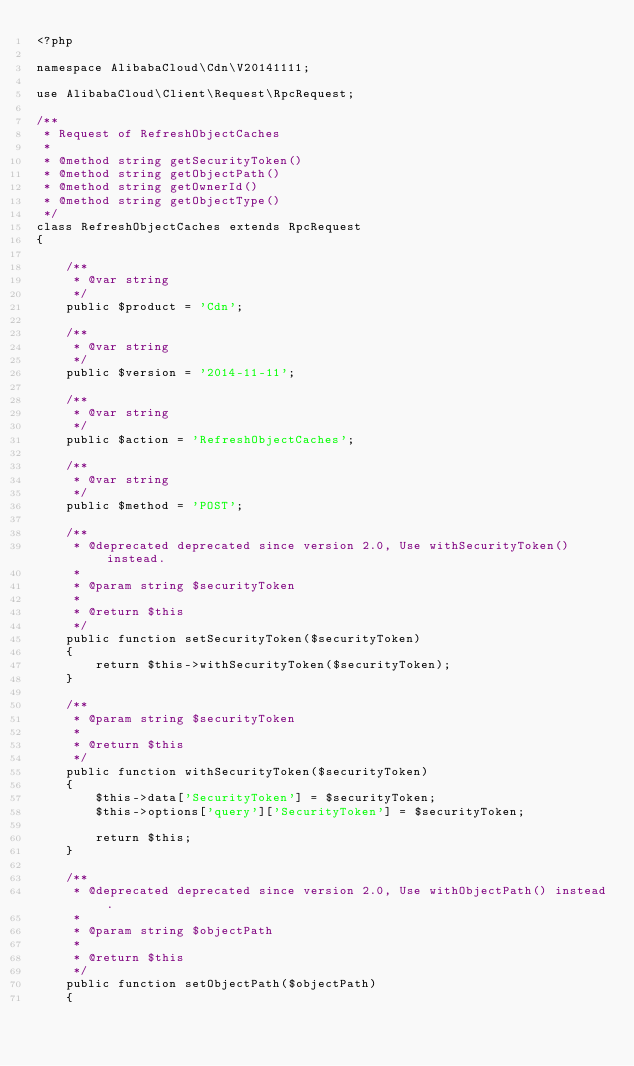Convert code to text. <code><loc_0><loc_0><loc_500><loc_500><_PHP_><?php

namespace AlibabaCloud\Cdn\V20141111;

use AlibabaCloud\Client\Request\RpcRequest;

/**
 * Request of RefreshObjectCaches
 *
 * @method string getSecurityToken()
 * @method string getObjectPath()
 * @method string getOwnerId()
 * @method string getObjectType()
 */
class RefreshObjectCaches extends RpcRequest
{

    /**
     * @var string
     */
    public $product = 'Cdn';

    /**
     * @var string
     */
    public $version = '2014-11-11';

    /**
     * @var string
     */
    public $action = 'RefreshObjectCaches';

    /**
     * @var string
     */
    public $method = 'POST';

    /**
     * @deprecated deprecated since version 2.0, Use withSecurityToken() instead.
     *
     * @param string $securityToken
     *
     * @return $this
     */
    public function setSecurityToken($securityToken)
    {
        return $this->withSecurityToken($securityToken);
    }

    /**
     * @param string $securityToken
     *
     * @return $this
     */
    public function withSecurityToken($securityToken)
    {
        $this->data['SecurityToken'] = $securityToken;
        $this->options['query']['SecurityToken'] = $securityToken;

        return $this;
    }

    /**
     * @deprecated deprecated since version 2.0, Use withObjectPath() instead.
     *
     * @param string $objectPath
     *
     * @return $this
     */
    public function setObjectPath($objectPath)
    {</code> 